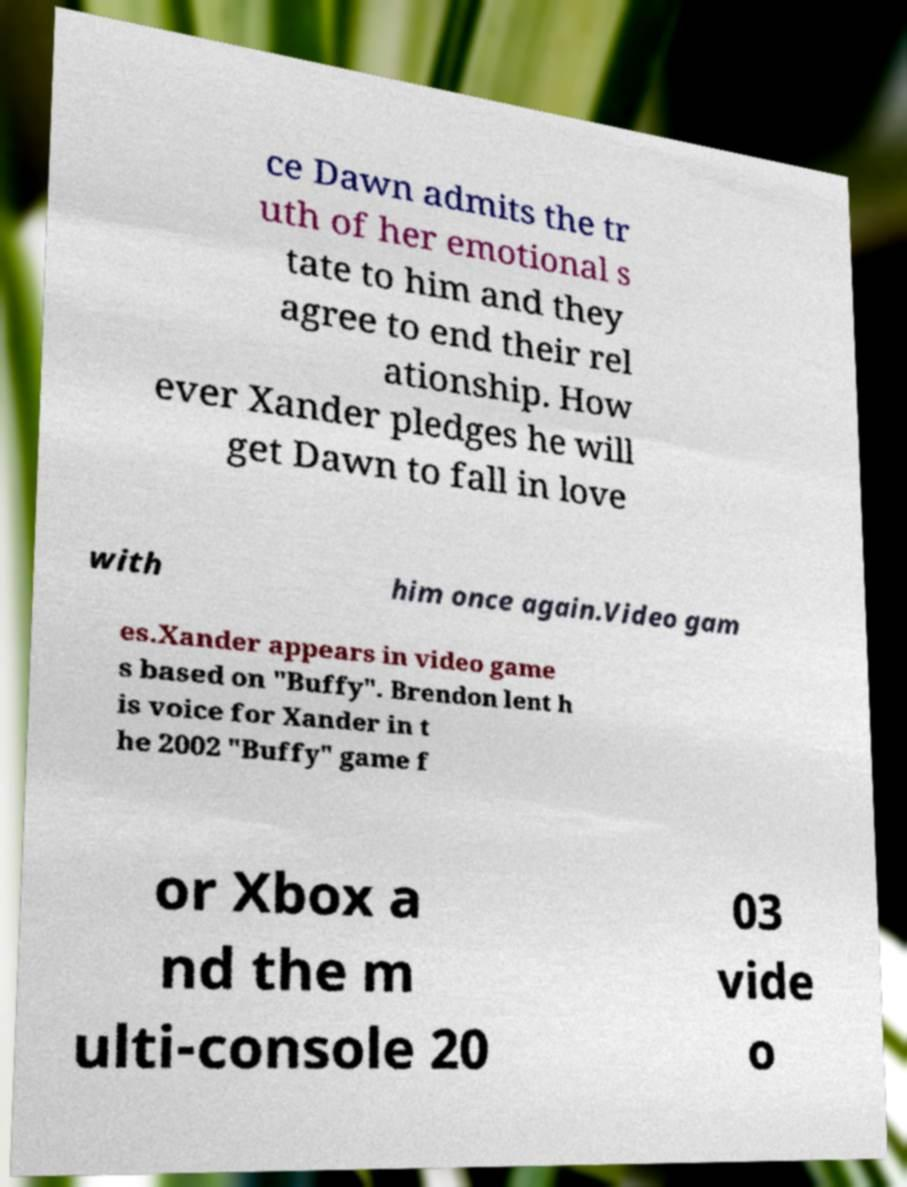Please identify and transcribe the text found in this image. ce Dawn admits the tr uth of her emotional s tate to him and they agree to end their rel ationship. How ever Xander pledges he will get Dawn to fall in love with him once again.Video gam es.Xander appears in video game s based on "Buffy". Brendon lent h is voice for Xander in t he 2002 "Buffy" game f or Xbox a nd the m ulti-console 20 03 vide o 